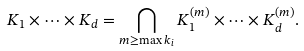Convert formula to latex. <formula><loc_0><loc_0><loc_500><loc_500>K _ { 1 } \times \dots \times K _ { d } = \bigcap _ { m \geq \max k _ { i } } K _ { 1 } ^ { ( m ) } \times \dots \times K _ { d } ^ { ( m ) } .</formula> 